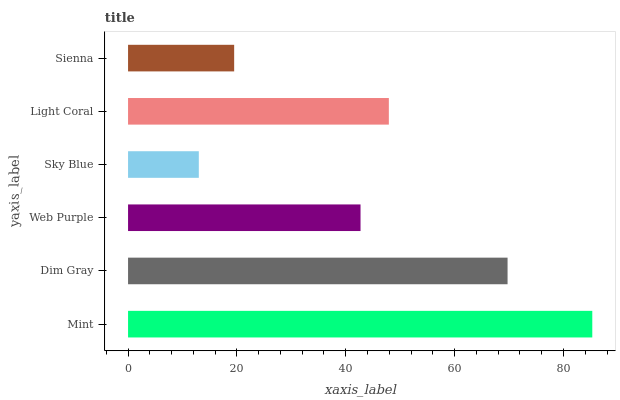Is Sky Blue the minimum?
Answer yes or no. Yes. Is Mint the maximum?
Answer yes or no. Yes. Is Dim Gray the minimum?
Answer yes or no. No. Is Dim Gray the maximum?
Answer yes or no. No. Is Mint greater than Dim Gray?
Answer yes or no. Yes. Is Dim Gray less than Mint?
Answer yes or no. Yes. Is Dim Gray greater than Mint?
Answer yes or no. No. Is Mint less than Dim Gray?
Answer yes or no. No. Is Light Coral the high median?
Answer yes or no. Yes. Is Web Purple the low median?
Answer yes or no. Yes. Is Sienna the high median?
Answer yes or no. No. Is Dim Gray the low median?
Answer yes or no. No. 